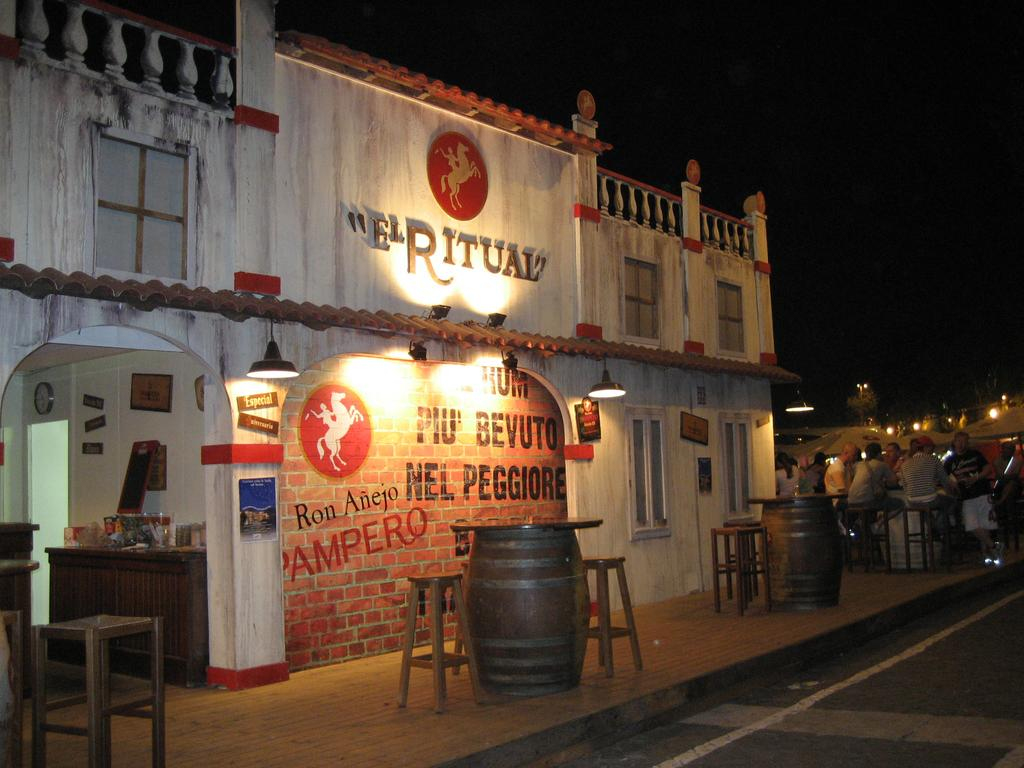<image>
Share a concise interpretation of the image provided. A storefront has a spotlight on "El Ritual." 